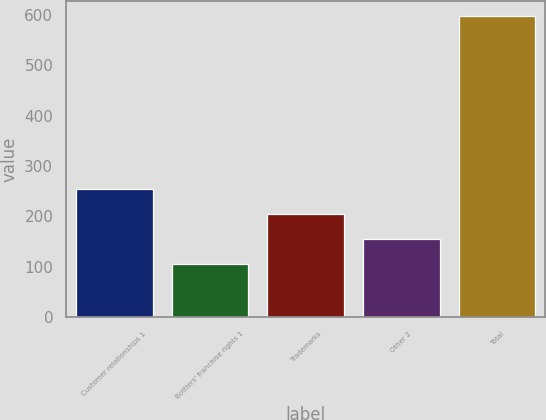<chart> <loc_0><loc_0><loc_500><loc_500><bar_chart><fcel>Customer relationships 1<fcel>Bottlers' franchise rights 1<fcel>Trademarks<fcel>Other 2<fcel>Total<nl><fcel>253.6<fcel>106<fcel>204.4<fcel>155.2<fcel>598<nl></chart> 